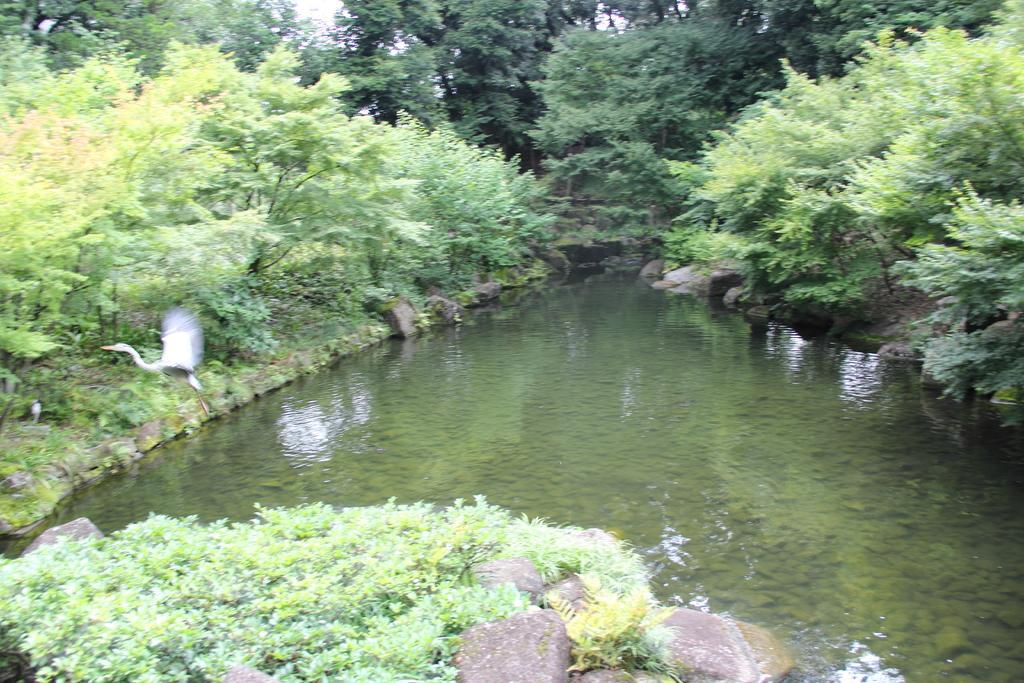Please provide a concise description of this image. Here in this picture we can see water present over a place and we can also see rock stones present on the ground and we can also see the ground is covered with grass, plants and trees. 